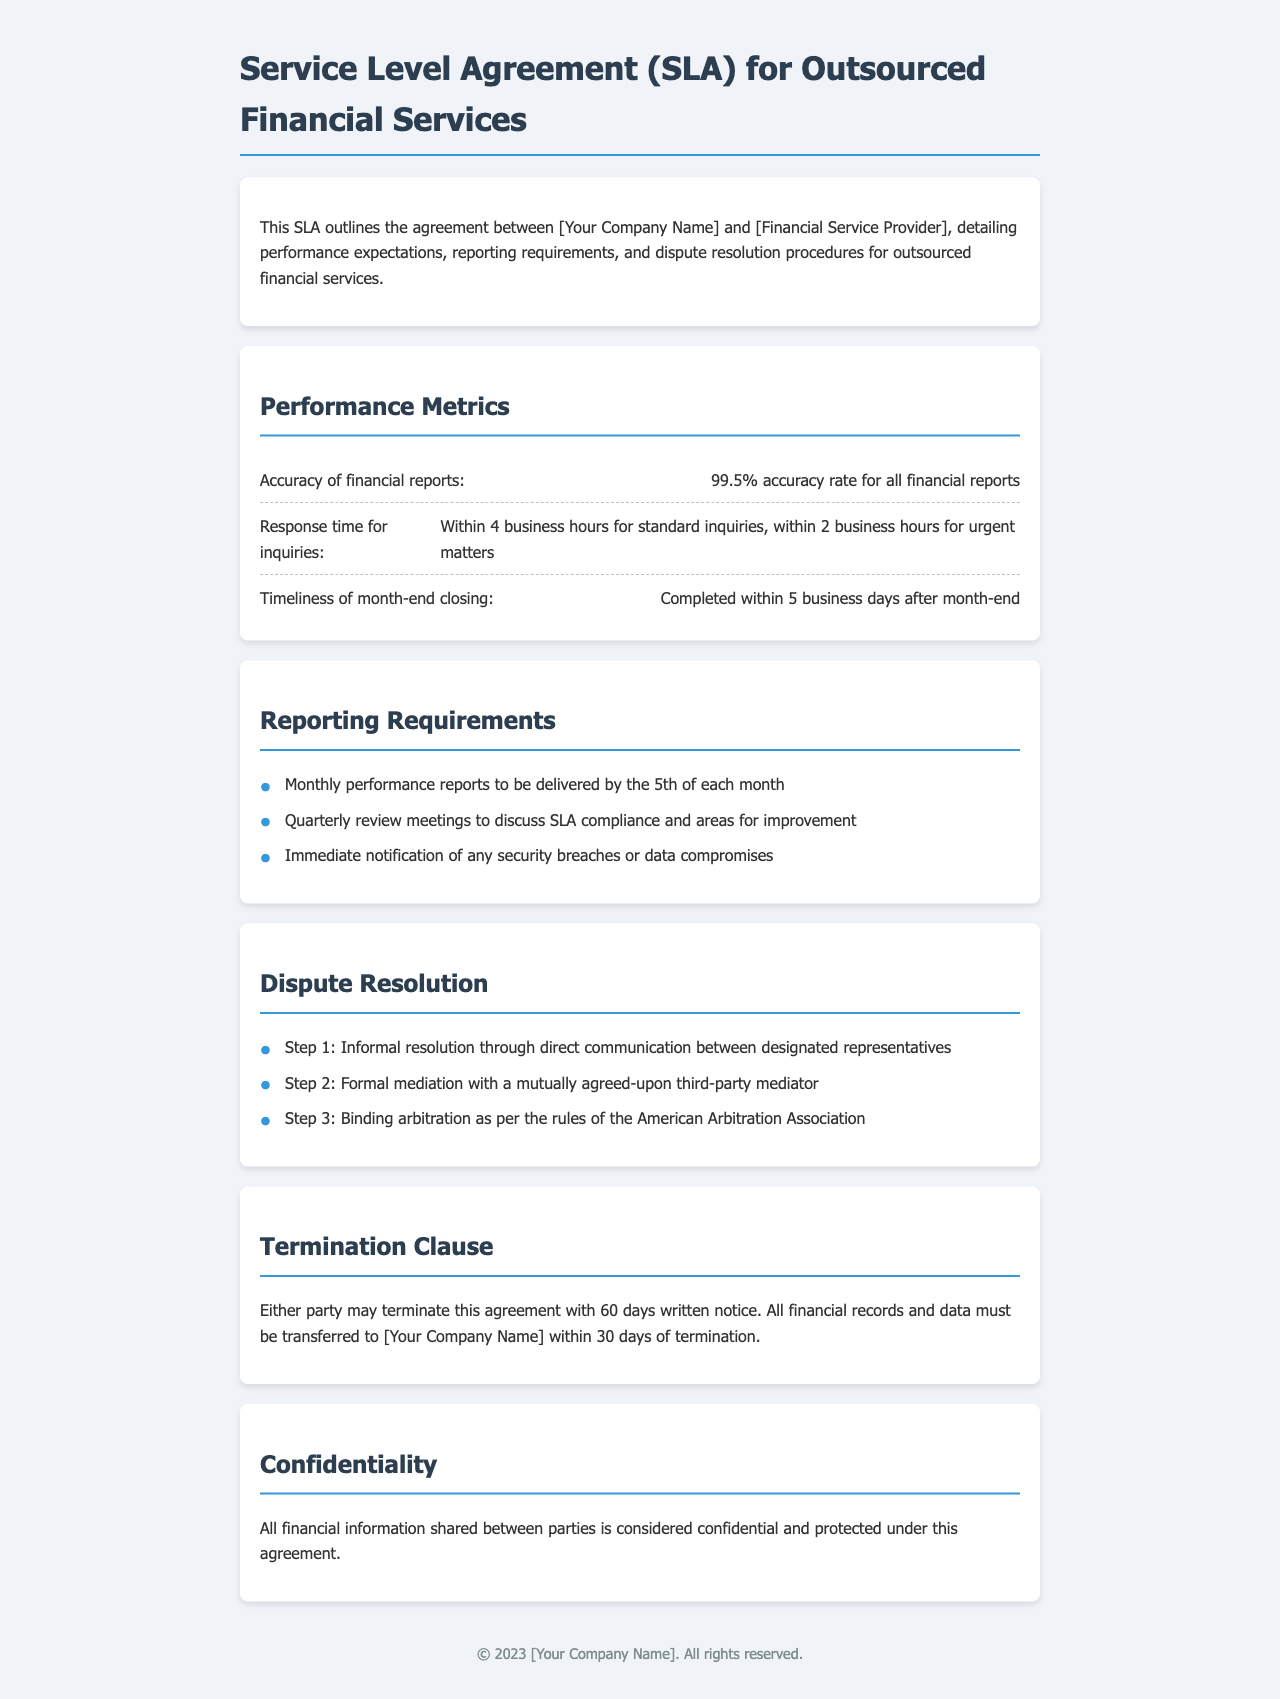What is the accuracy rate for financial reports? The SLA specifies a 99.5% accuracy rate for all financial reports.
Answer: 99.5% What is the response time for urgent inquiries? According to the document, the response time for urgent inquiries is within 2 business hours.
Answer: Within 2 business hours When must monthly performance reports be delivered? The document states that monthly performance reports are to be delivered by the 5th of each month.
Answer: By the 5th of each month What is the first step in the dispute resolution process? The first step outlined in the document is informal resolution through direct communication between designated representatives.
Answer: Informal resolution How many days written notice is required for termination? The SLA requires 60 days written notice for termination of the agreement.
Answer: 60 days What is the timeline for month-end closing completion? The document indicates that month-end closing should be completed within 5 business days after month-end.
Answer: Within 5 business days What happens to financial records upon termination? According to the SLA, all financial records and data must be transferred to [Your Company Name] within 30 days of termination.
Answer: Within 30 days How often are quarterly review meetings held? The document states that quarterly review meetings are held to discuss SLA compliance and areas for improvement.
Answer: Quarterly What level of confidentiality is guaranteed for financial information? The document states that all financial information shared between parties is considered confidential and protected under this agreement.
Answer: Confidential 